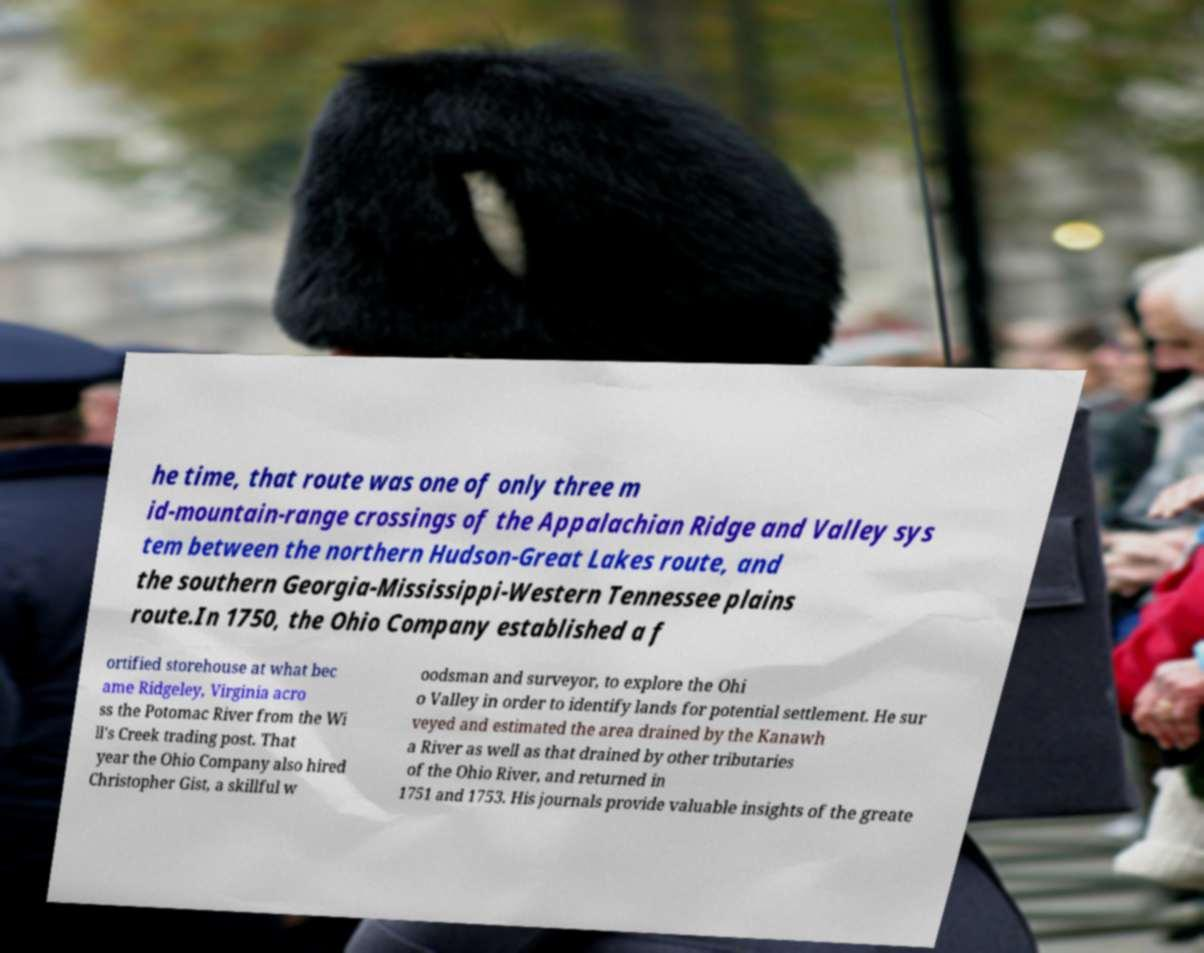Could you extract and type out the text from this image? he time, that route was one of only three m id-mountain-range crossings of the Appalachian Ridge and Valley sys tem between the northern Hudson-Great Lakes route, and the southern Georgia-Mississippi-Western Tennessee plains route.In 1750, the Ohio Company established a f ortified storehouse at what bec ame Ridgeley, Virginia acro ss the Potomac River from the Wi ll's Creek trading post. That year the Ohio Company also hired Christopher Gist, a skillful w oodsman and surveyor, to explore the Ohi o Valley in order to identify lands for potential settlement. He sur veyed and estimated the area drained by the Kanawh a River as well as that drained by other tributaries of the Ohio River, and returned in 1751 and 1753. His journals provide valuable insights of the greate 